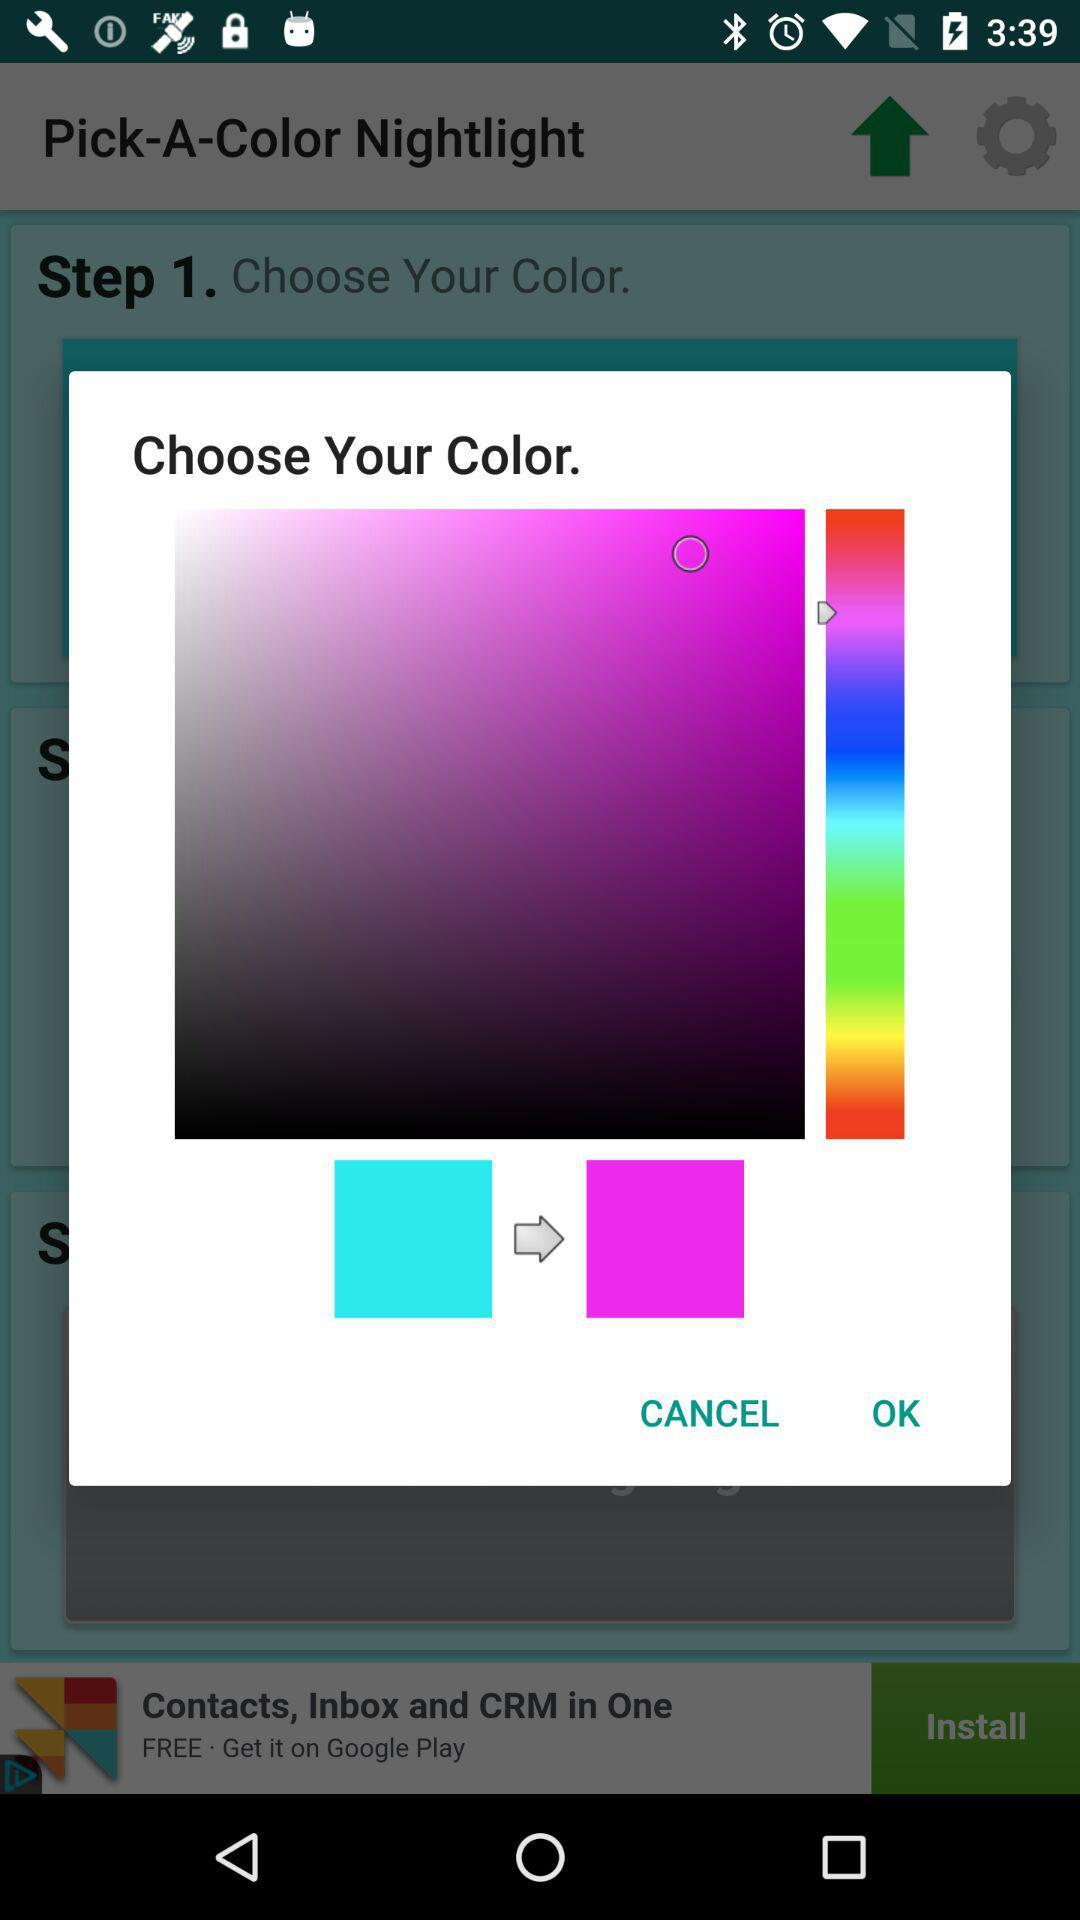What steps are currently shown? The step which is currently shown is 1. 